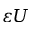Convert formula to latex. <formula><loc_0><loc_0><loc_500><loc_500>{ \varepsilon } U</formula> 